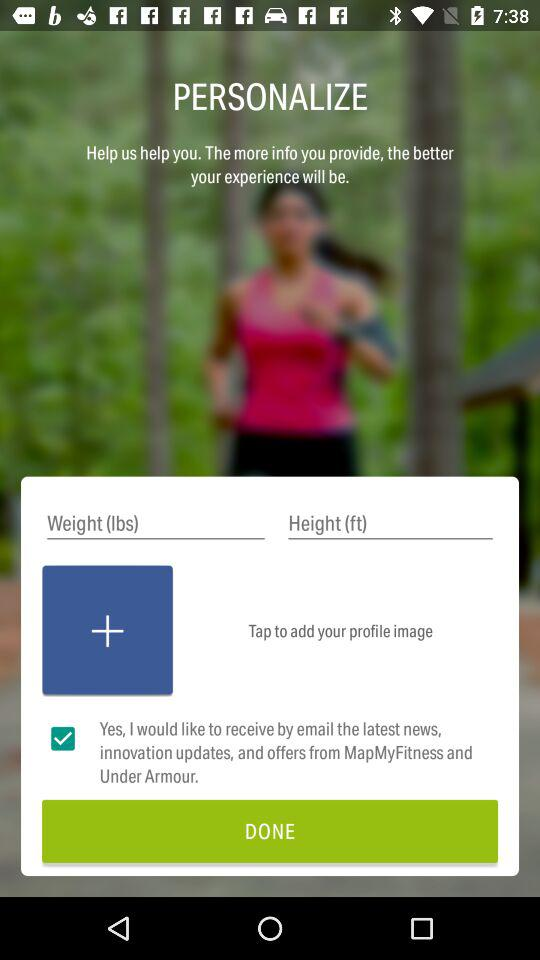How many more text inputs are there than checkboxes?
Answer the question using a single word or phrase. 1 